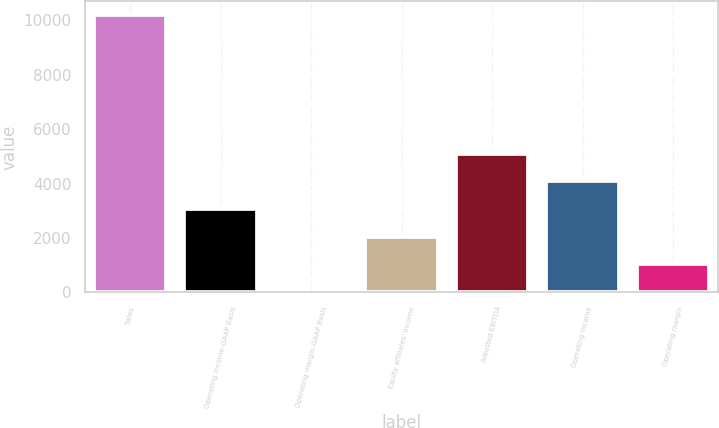Convert chart to OTSL. <chart><loc_0><loc_0><loc_500><loc_500><bar_chart><fcel>Sales<fcel>Operating income-GAAP Basis<fcel>Operating margin-GAAP Basis<fcel>Equity affiliates' income<fcel>Adjusted EBITDA<fcel>Operating income<fcel>Operating margin<nl><fcel>10180.4<fcel>3063.22<fcel>13<fcel>2046.48<fcel>5096.7<fcel>4079.96<fcel>1029.74<nl></chart> 